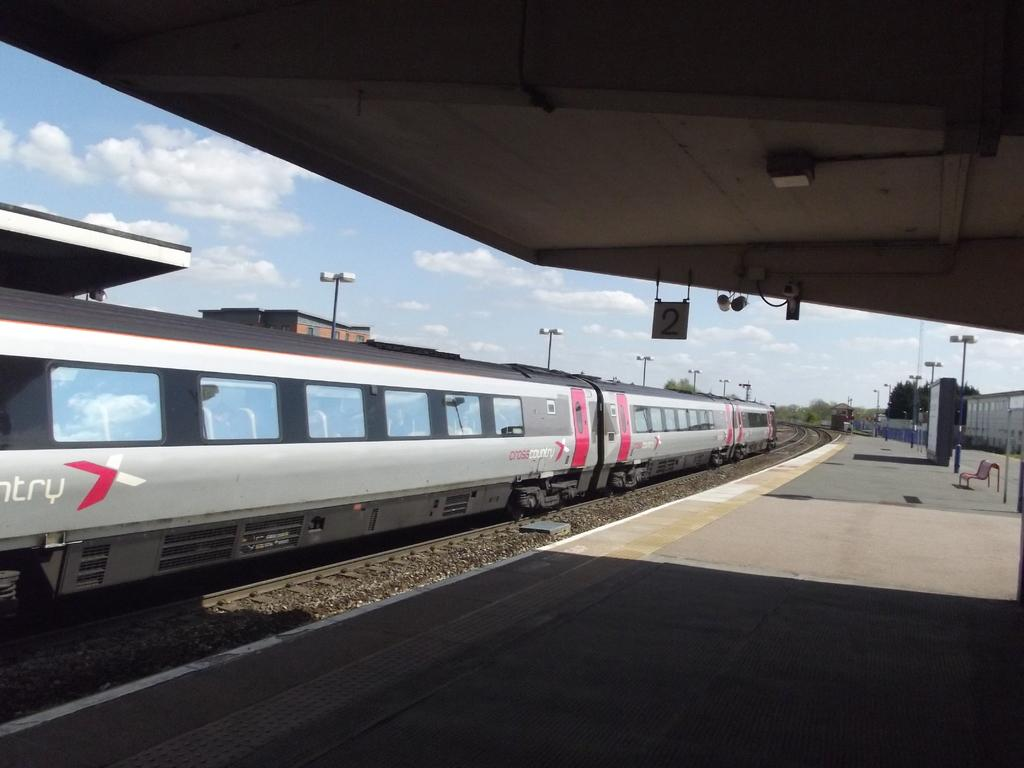What type of vehicle is on the track in the image? There is a locomotive on the track in the image. What structure is present near the track? There is a platform in the image. What are the tall, vertical structures near the platform? Street poles are visible in the image. What are the lights attached to the street poles used for? Street lights are present in the image. What signs are visible in the image? Number boards are in the image. What type of buildings can be seen in the image? There are sheds in the image. What type of vegetation is visible in the image? Trees are visible in the image. What is visible in the top part of the image? The sky is visible in the image, and clouds are present in the sky. Where is the garden located in the image? There is no garden present in the image. What type of cap is the locomotive wearing in the image? The locomotive does not have a cap; it is a vehicle and does not wear clothing or accessories. 